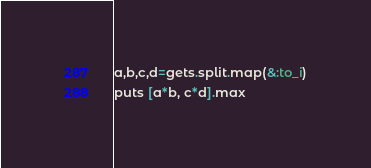<code> <loc_0><loc_0><loc_500><loc_500><_Ruby_>a,b,c,d=gets.split.map(&:to_i)
puts [a*b, c*d].max
</code> 